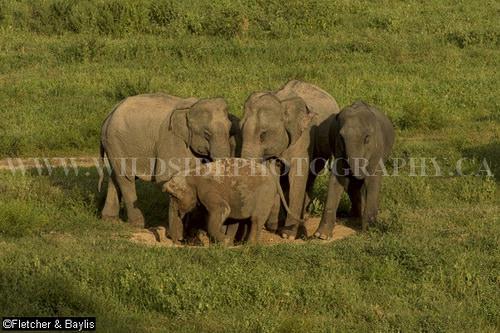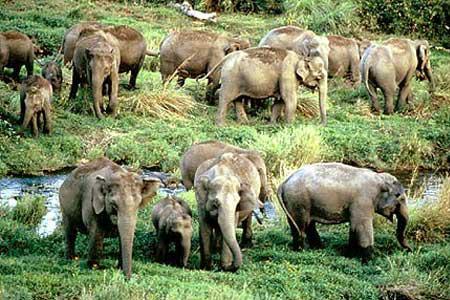The first image is the image on the left, the second image is the image on the right. Analyze the images presented: Is the assertion "A water hole is present in a scene with multiple elephants of different ages." valid? Answer yes or no. Yes. The first image is the image on the left, the second image is the image on the right. Evaluate the accuracy of this statement regarding the images: "Elephants are standing in or beside water in the right image.". Is it true? Answer yes or no. Yes. 